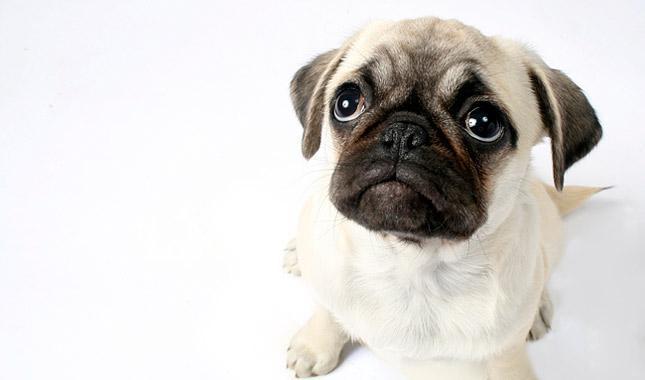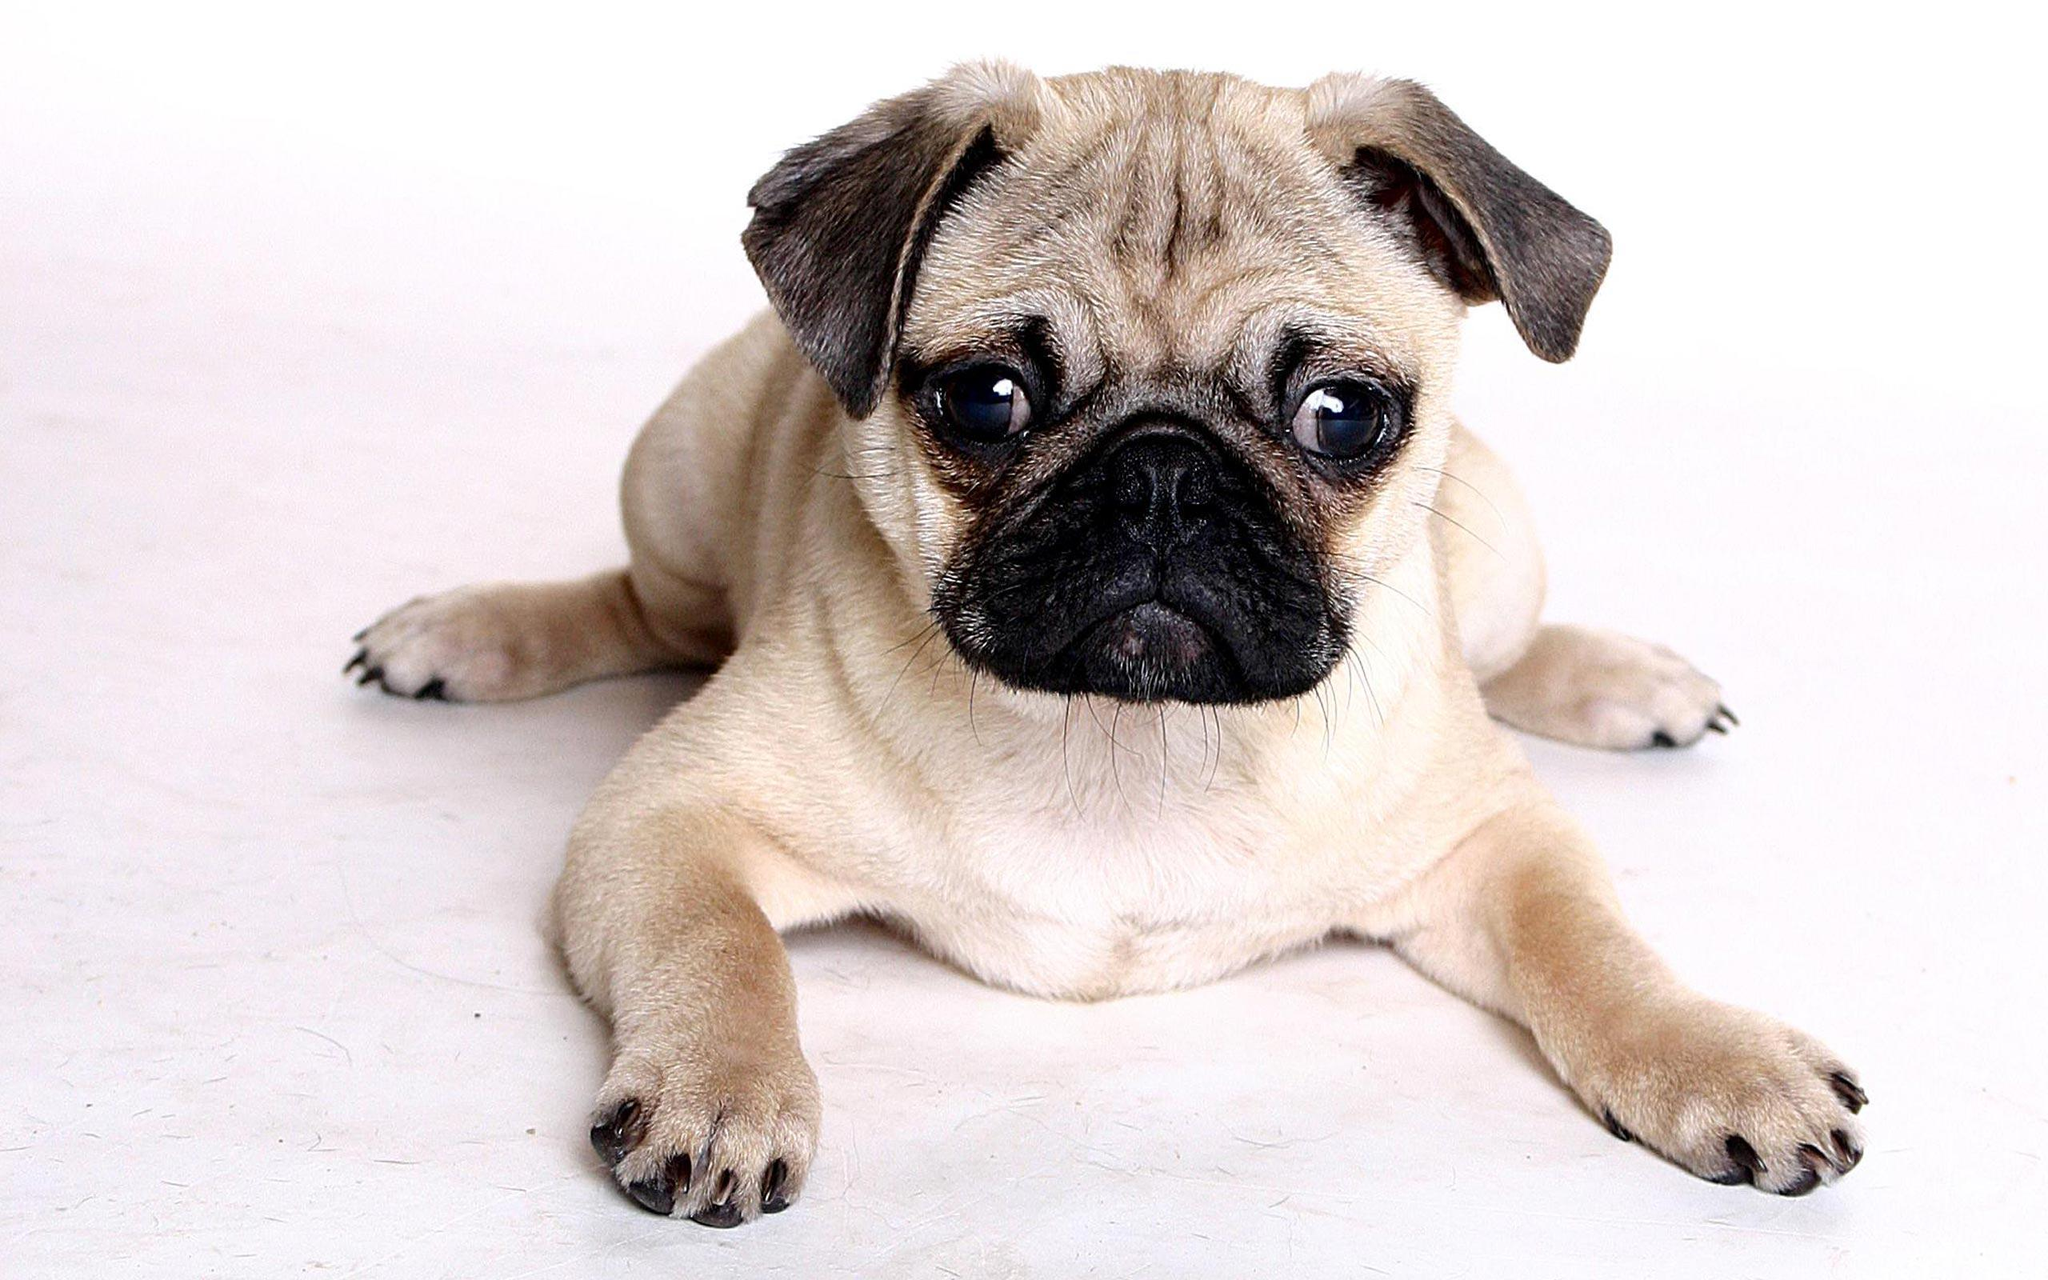The first image is the image on the left, the second image is the image on the right. For the images shown, is this caption "In total, two pug tails are visible." true? Answer yes or no. No. 